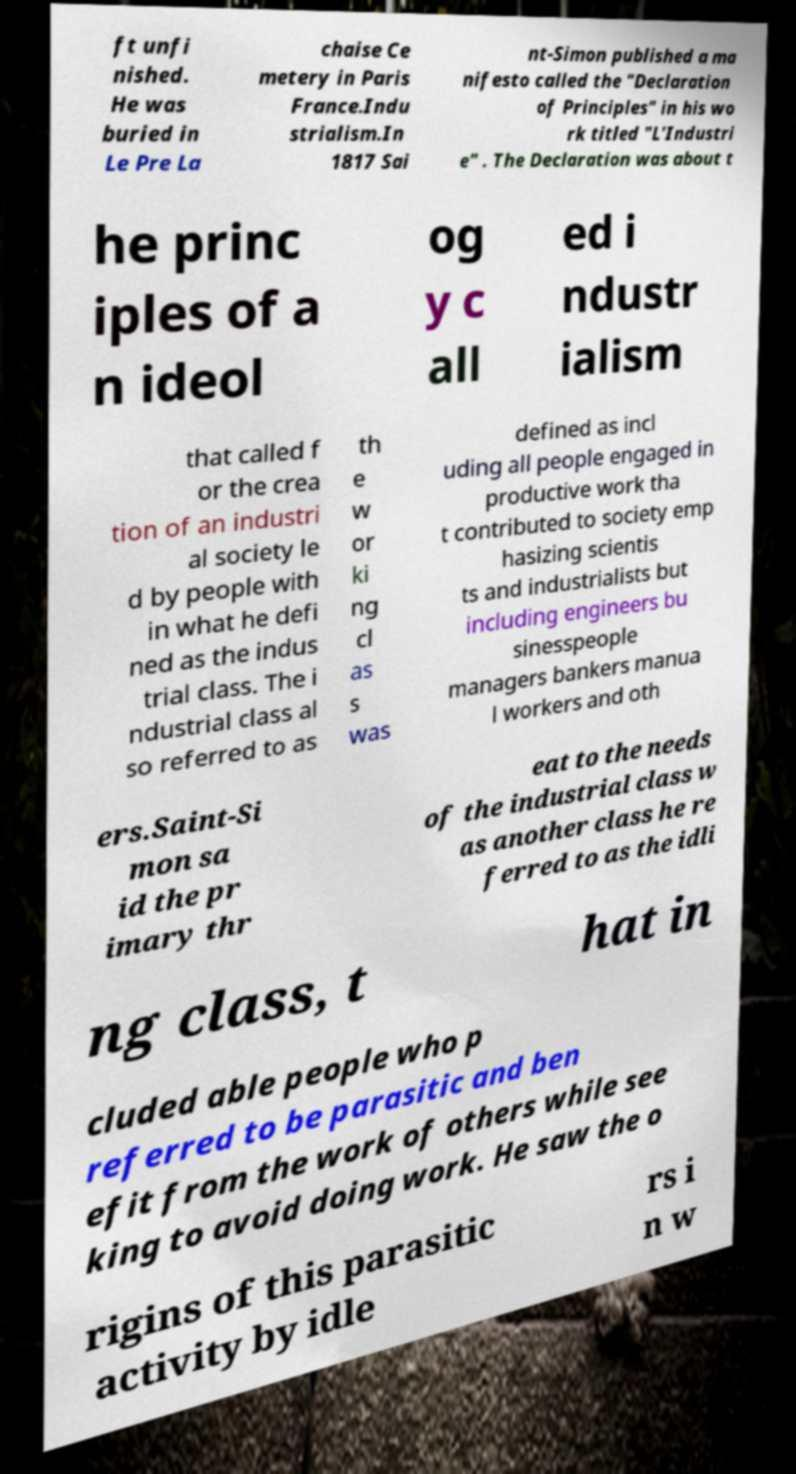Can you accurately transcribe the text from the provided image for me? ft unfi nished. He was buried in Le Pre La chaise Ce metery in Paris France.Indu strialism.In 1817 Sai nt-Simon published a ma nifesto called the "Declaration of Principles" in his wo rk titled "L'Industri e" . The Declaration was about t he princ iples of a n ideol og y c all ed i ndustr ialism that called f or the crea tion of an industri al society le d by people with in what he defi ned as the indus trial class. The i ndustrial class al so referred to as th e w or ki ng cl as s was defined as incl uding all people engaged in productive work tha t contributed to society emp hasizing scientis ts and industrialists but including engineers bu sinesspeople managers bankers manua l workers and oth ers.Saint-Si mon sa id the pr imary thr eat to the needs of the industrial class w as another class he re ferred to as the idli ng class, t hat in cluded able people who p referred to be parasitic and ben efit from the work of others while see king to avoid doing work. He saw the o rigins of this parasitic activity by idle rs i n w 